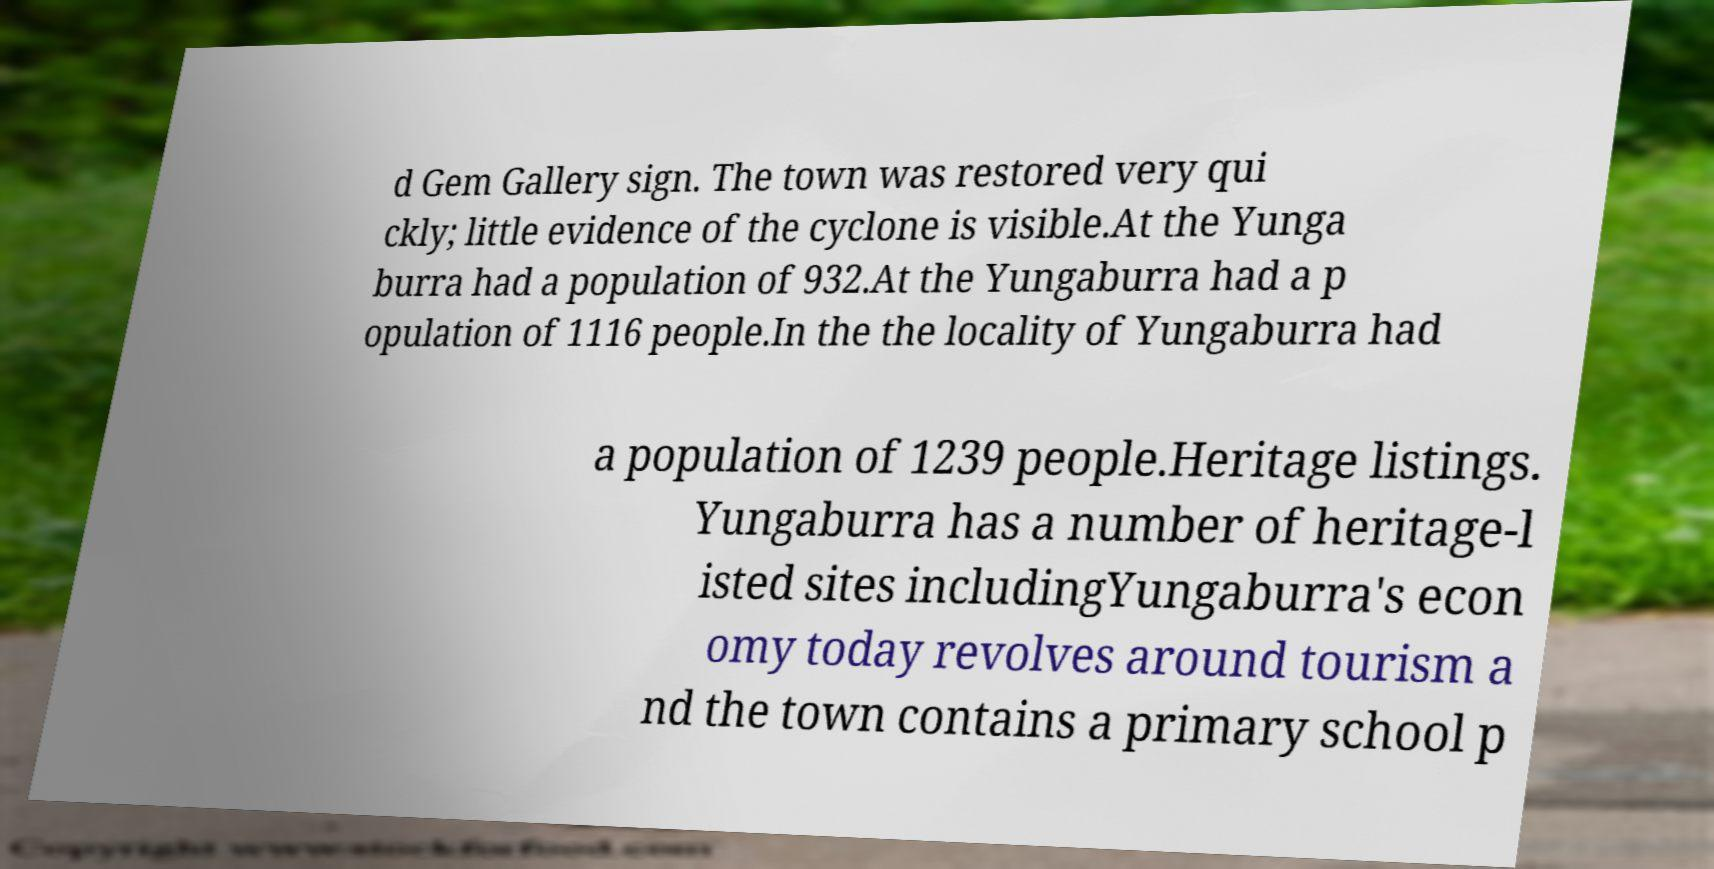Can you read and provide the text displayed in the image?This photo seems to have some interesting text. Can you extract and type it out for me? d Gem Gallery sign. The town was restored very qui ckly; little evidence of the cyclone is visible.At the Yunga burra had a population of 932.At the Yungaburra had a p opulation of 1116 people.In the the locality of Yungaburra had a population of 1239 people.Heritage listings. Yungaburra has a number of heritage-l isted sites includingYungaburra's econ omy today revolves around tourism a nd the town contains a primary school p 